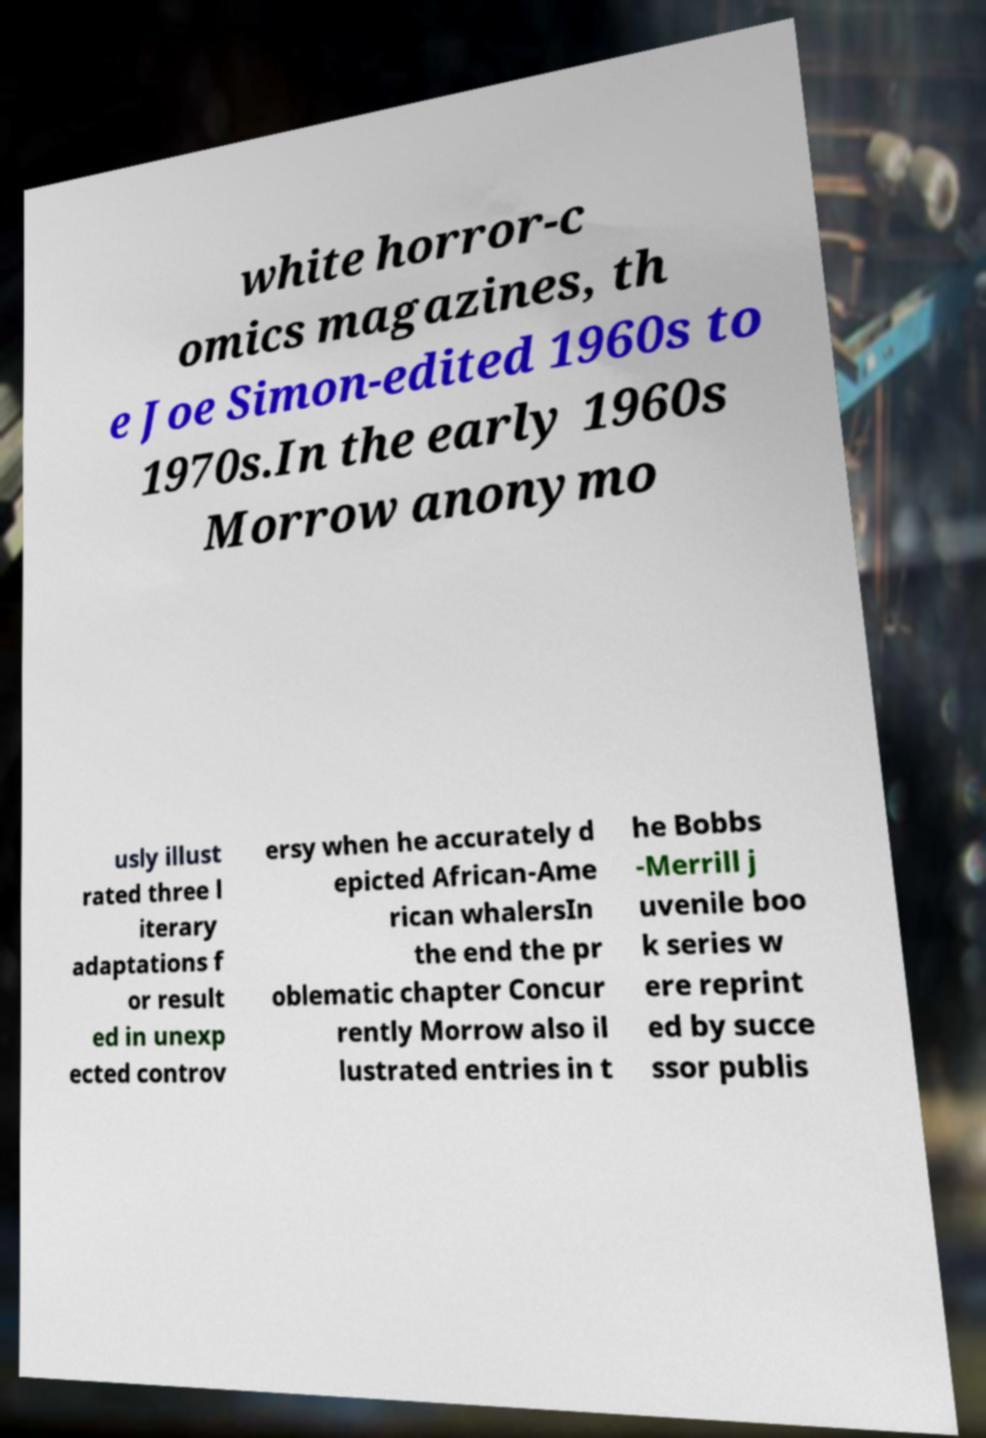Please read and relay the text visible in this image. What does it say? white horror-c omics magazines, th e Joe Simon-edited 1960s to 1970s.In the early 1960s Morrow anonymo usly illust rated three l iterary adaptations f or result ed in unexp ected controv ersy when he accurately d epicted African-Ame rican whalersIn the end the pr oblematic chapter Concur rently Morrow also il lustrated entries in t he Bobbs -Merrill j uvenile boo k series w ere reprint ed by succe ssor publis 